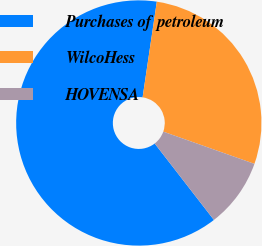Convert chart. <chart><loc_0><loc_0><loc_500><loc_500><pie_chart><fcel>Purchases of petroleum<fcel>WilcoHess<fcel>HOVENSA<nl><fcel>62.84%<fcel>28.06%<fcel>9.1%<nl></chart> 